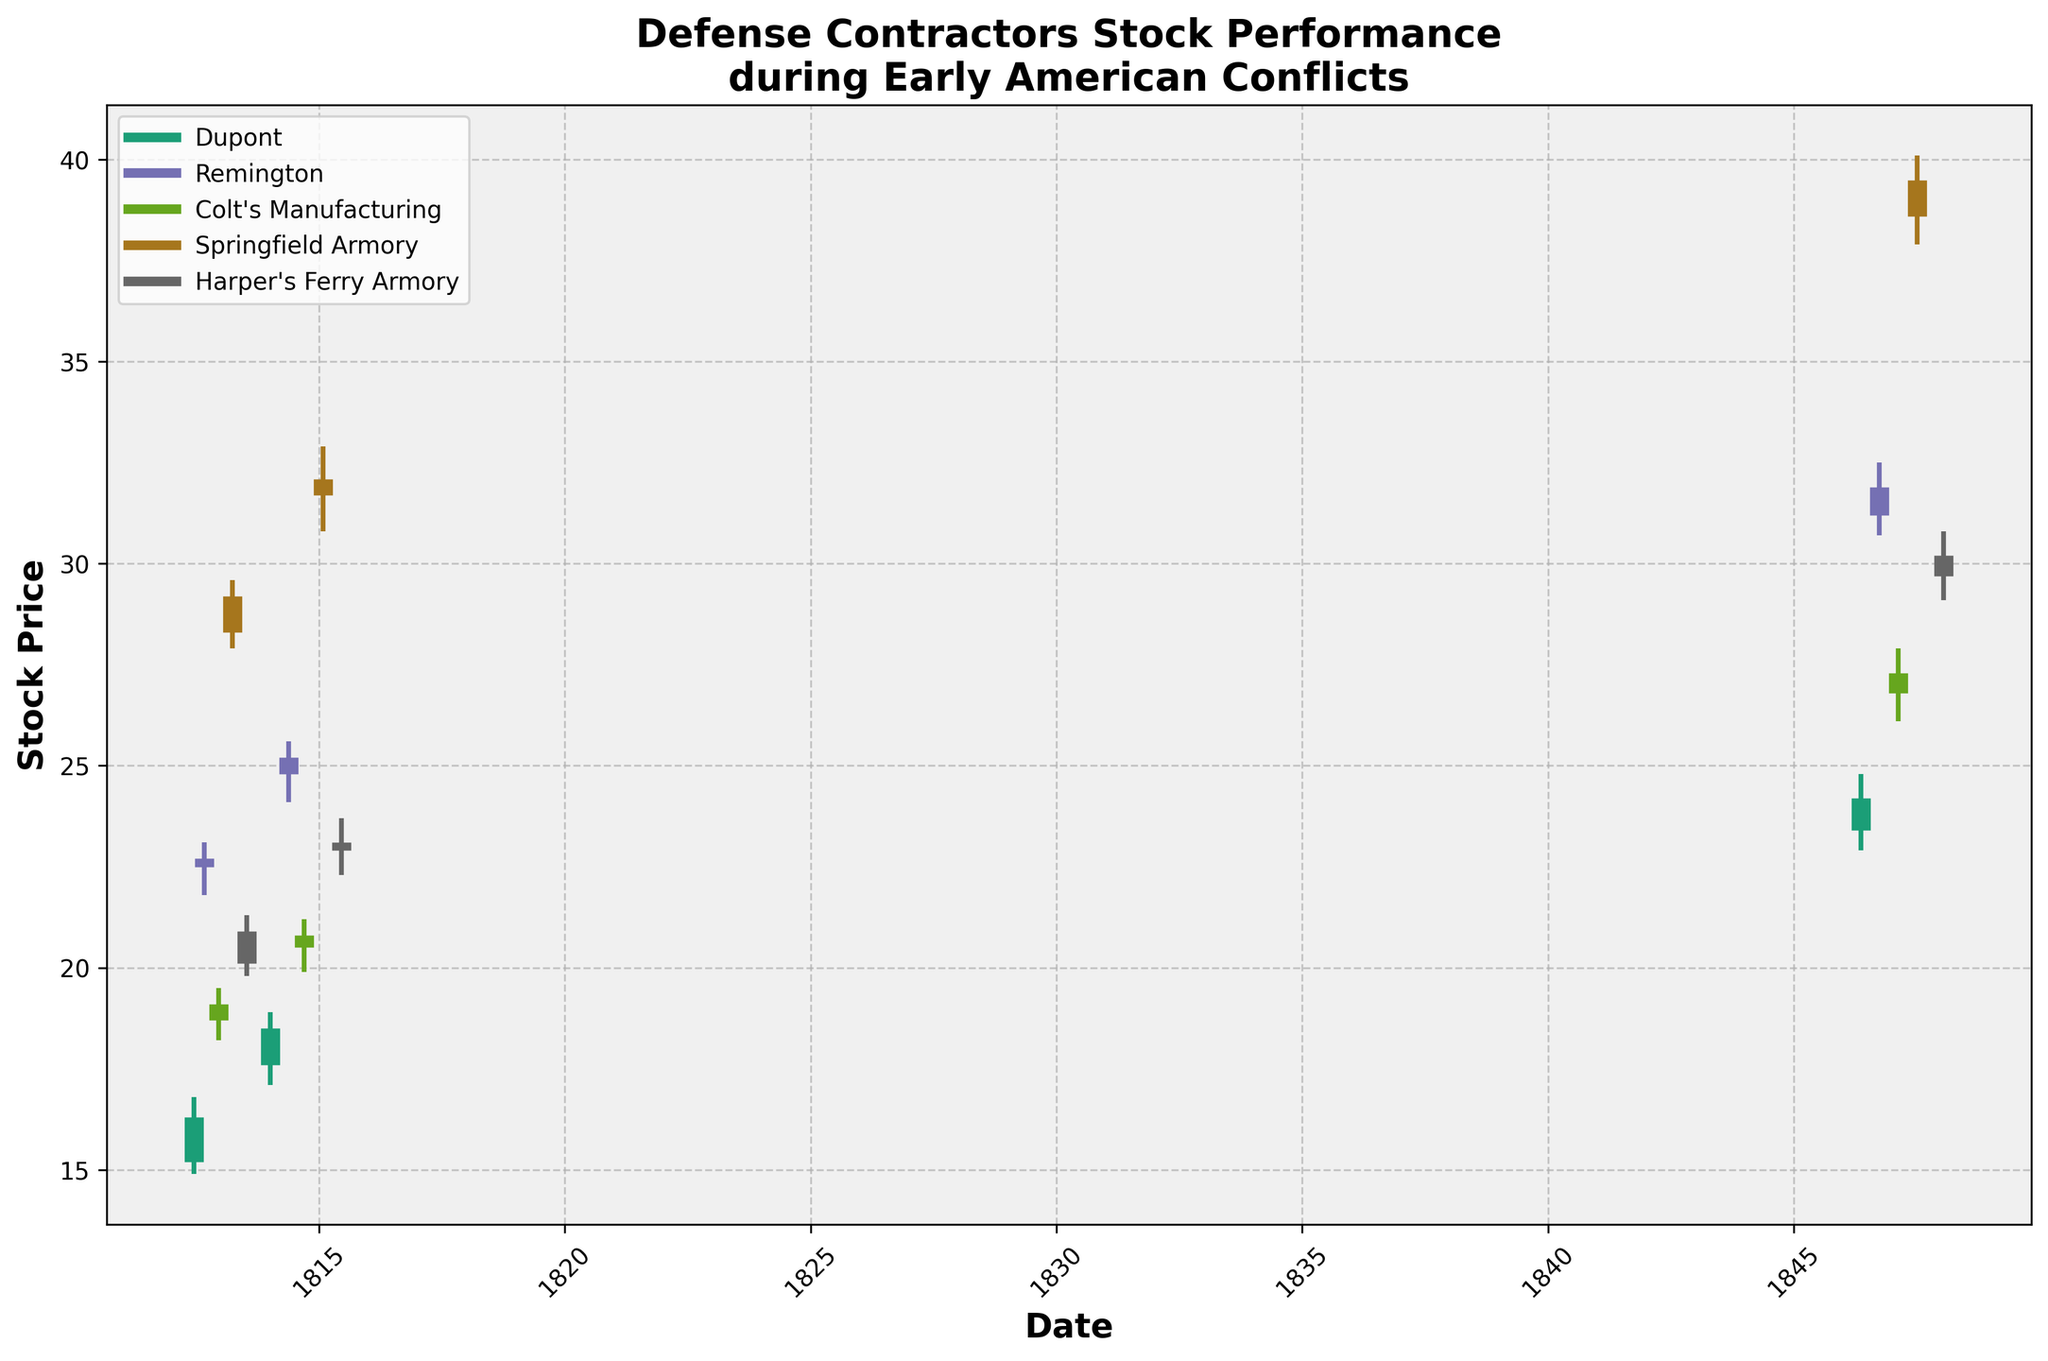What's the title of the figure? The title of the figure is displayed prominently at the top. It reads "Defense Contractors Stock Performance\nduring Early American Conflicts."
Answer: Defense Contractors Stock Performance\nduring Early American Conflicts How many companies are represented in the figure? There are different colors representing the various companies in the OHLC chart. By counting the unique colors, you can see there are 5 companies.
Answer: 5 Which company had the highest stock price on the last date recorded in the data? The last date is 1848-01-19 for Harper's Ferry Armory. From the figure, the highest point on this company’s line reaches 30.8.
Answer: Harper's Ferry Armory What was Dupont's stock close price on January 5, 1814? The figure shows Dupont's stock performance using a specific color. On January 5, 1814, the thicker mark on Dupont's line which represents the closing price is at 18.5.
Answer: 18.5 Compare the stock price performance of Remington between May 13, 1846, and September 28, 1846. For May 13, 1846, the close price of Remington reached approximately 24.2, and on September 28, 1846, it closed at around 31.9. The increase can be observed by comparing the two points on the chart.
Answer: It increased Which company had the lowest closing price on June 18, 1812? By checking the lowest point among the closing prices of the companies on June 18, 1812, Dupont has the closing price of around 16.3, this seems to be the lowest compared to others on similar dates.
Answer: Dupont During which period did Springfield Armory show a significant increase in stock price? Observing the Springfield Armory's line on the chart, there’s a noticeable upward trend from its initial point on March 30, 1813, to its later points, particularly significant around January 30, 1815.
Answer: Between March 30, 1813, and January 30, 1815 What is the color used for depicting Colt's Manufacturing's data? By matching the color used for the label of Colt's Manufacturing in the legend to the corresponding lines within the chart, it's pink.
Answer: Pink What was the highest high price recorded for Remington? From the different vertical lines representing the high prices for Remington across various dates, the highest point sieves Remington high to approximately 32.5, occurring on September 28, 1846.
Answer: 32.5 Did Harper's Ferry Armory see any significant price volatility? On observing the length of the vertical lines representing high and low prices for Harper's Ferry Armory across various dates—specifically significant fluctuation around July 14, 1813—they show considerable fluctuations suggesting high volatility.
Answer: Yes 